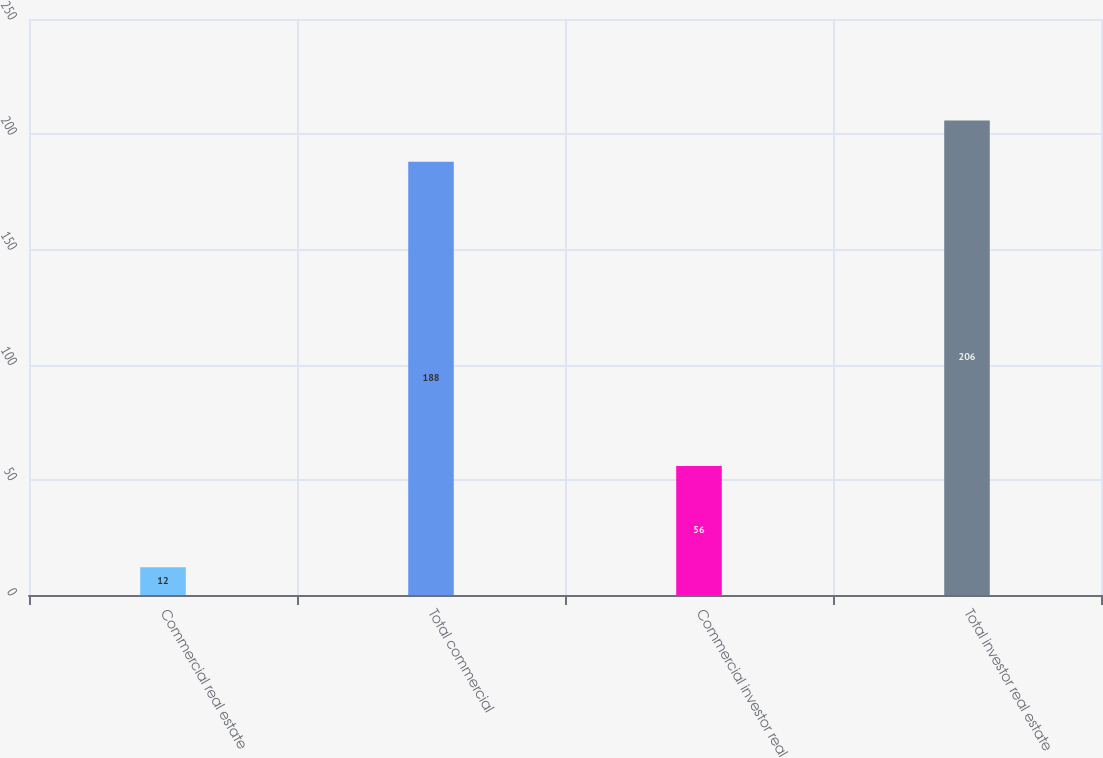Convert chart. <chart><loc_0><loc_0><loc_500><loc_500><bar_chart><fcel>Commercial real estate<fcel>Total commercial<fcel>Commercial investor real<fcel>Total investor real estate<nl><fcel>12<fcel>188<fcel>56<fcel>206<nl></chart> 